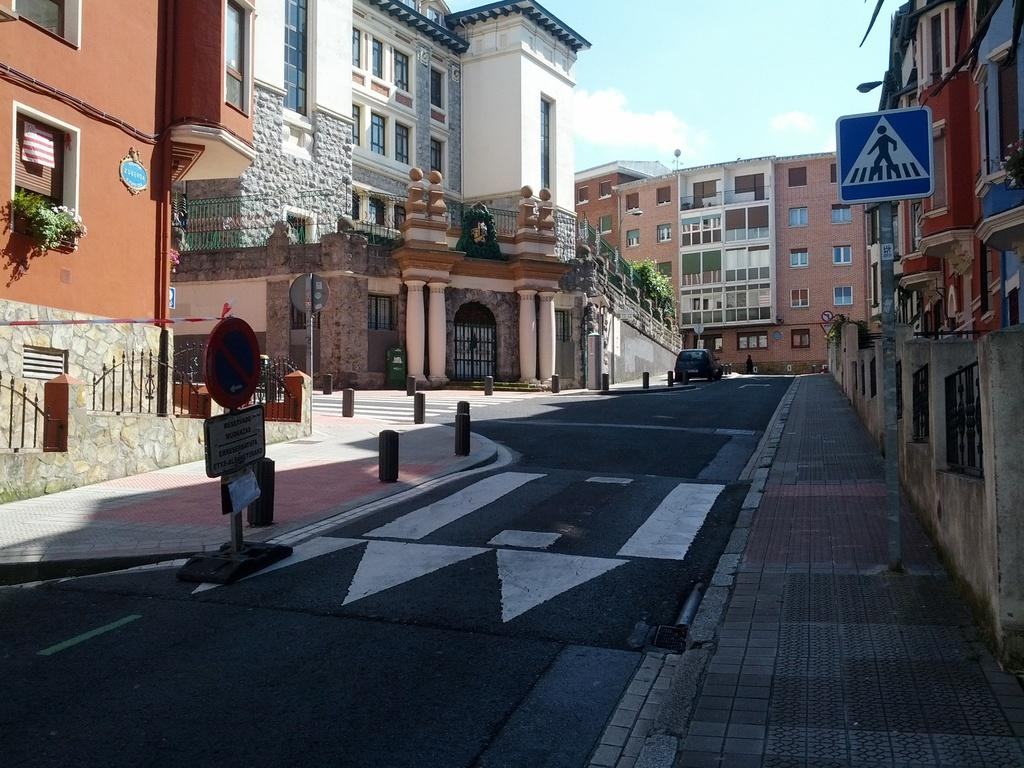What is on the road in the image? There is a vehicle on the road in the image. What can be seen near the road? There are sign boards in the image. What type of structures are visible in the image? There are buildings with windows in the image. What type of vegetation is present in the image? There are plants in the image. What architectural elements can be seen in the image? There are pillars in the image. What type of wax is being used to create the representative's sculpture in the image? There is no representative or sculpture present in the image, so it is not possible to determine what type of wax might be used. 